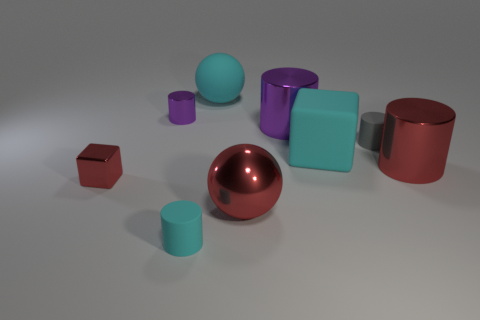Subtract all cyan cylinders. How many cylinders are left? 4 Subtract all cyan cubes. How many cubes are left? 1 Subtract 1 cyan spheres. How many objects are left? 8 Subtract all cylinders. How many objects are left? 4 Subtract 2 blocks. How many blocks are left? 0 Subtract all gray cylinders. Subtract all cyan spheres. How many cylinders are left? 4 Subtract all yellow cubes. How many green cylinders are left? 0 Subtract all gray things. Subtract all big metallic spheres. How many objects are left? 7 Add 8 purple shiny cylinders. How many purple shiny cylinders are left? 10 Add 5 spheres. How many spheres exist? 7 